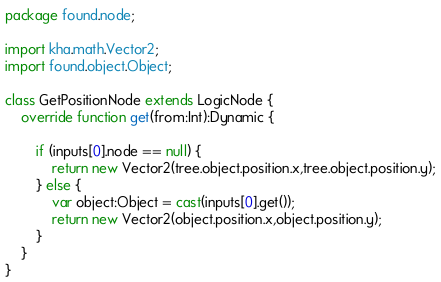Convert code to text. <code><loc_0><loc_0><loc_500><loc_500><_Haxe_>package found.node;

import kha.math.Vector2;
import found.object.Object;

class GetPositionNode extends LogicNode {
	override function get(from:Int):Dynamic {
		
		if (inputs[0].node == null) {
			return new Vector2(tree.object.position.x,tree.object.position.y);
		} else {
			var object:Object = cast(inputs[0].get());
			return new Vector2(object.position.x,object.position.y);
		}
	}
}
</code> 